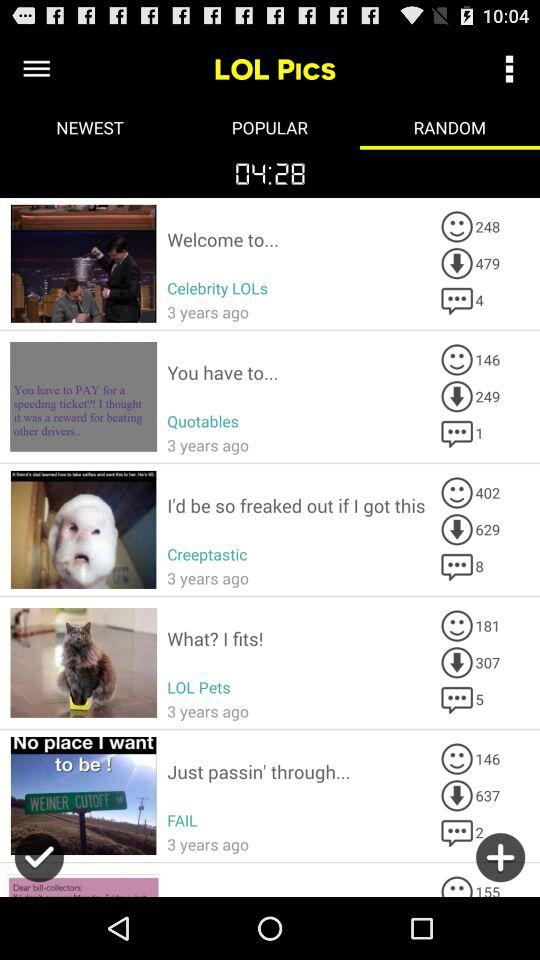How many comments are there on "Creeptastic"? There are 8 comments on "Creeptastic". 